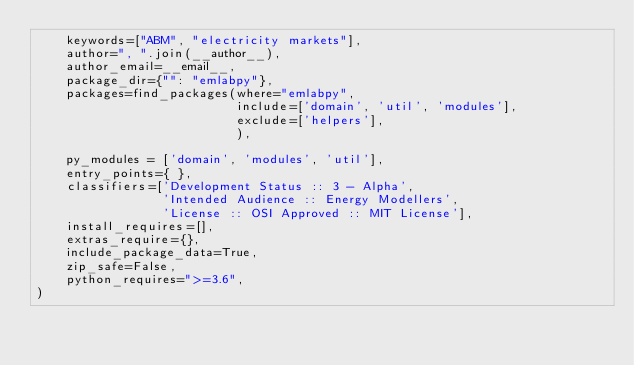<code> <loc_0><loc_0><loc_500><loc_500><_Python_>    keywords=["ABM", "electricity markets"],
    author=", ".join(__author__),
    author_email=__email__,
    package_dir={"": "emlabpy"},
    packages=find_packages(where="emlabpy",
                           include=['domain', 'util', 'modules'],
                           exclude=['helpers'],
                           ),

    py_modules = ['domain', 'modules', 'util'],
    entry_points={ },
    classifiers=['Development Status :: 3 - Alpha',
                 'Intended Audience :: Energy Modellers',
                 'License :: OSI Approved :: MIT License'],
    install_requires=[],
    extras_require={},
    include_package_data=True,
    zip_safe=False,
    python_requires=">=3.6",
)
</code> 